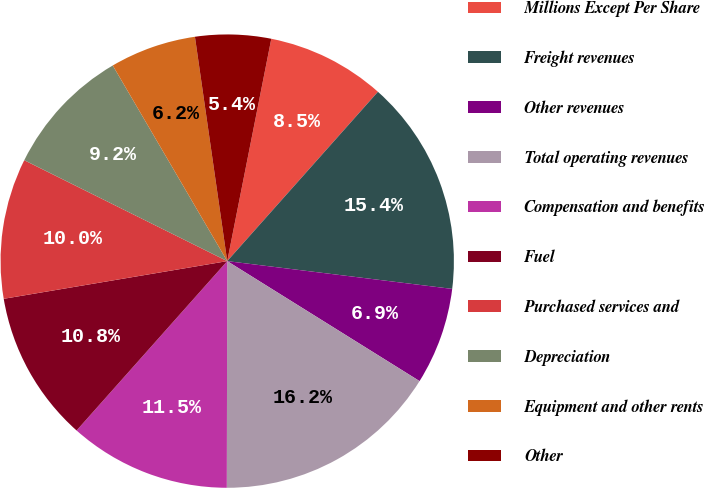Convert chart to OTSL. <chart><loc_0><loc_0><loc_500><loc_500><pie_chart><fcel>Millions Except Per Share<fcel>Freight revenues<fcel>Other revenues<fcel>Total operating revenues<fcel>Compensation and benefits<fcel>Fuel<fcel>Purchased services and<fcel>Depreciation<fcel>Equipment and other rents<fcel>Other<nl><fcel>8.46%<fcel>15.38%<fcel>6.92%<fcel>16.15%<fcel>11.54%<fcel>10.77%<fcel>10.0%<fcel>9.23%<fcel>6.15%<fcel>5.39%<nl></chart> 